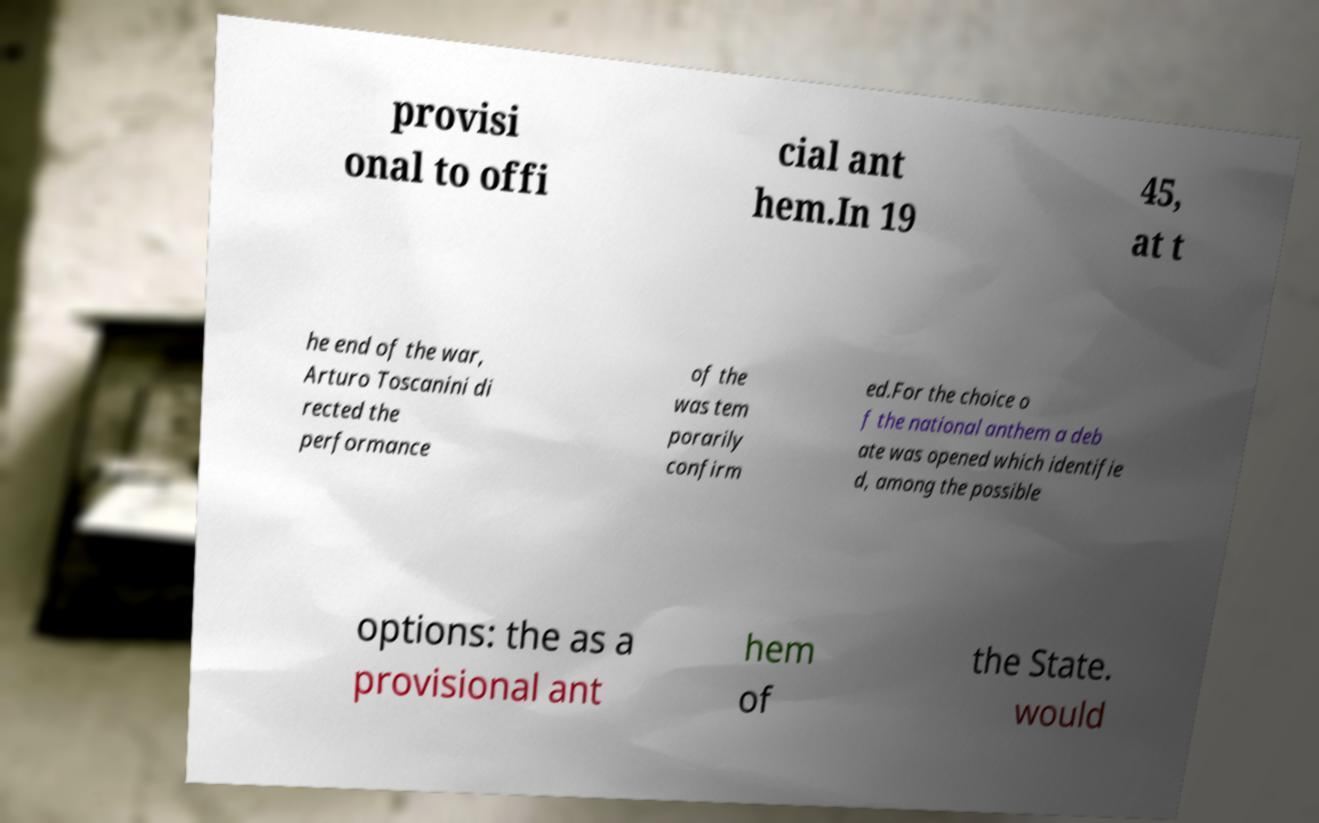I need the written content from this picture converted into text. Can you do that? provisi onal to offi cial ant hem.In 19 45, at t he end of the war, Arturo Toscanini di rected the performance of the was tem porarily confirm ed.For the choice o f the national anthem a deb ate was opened which identifie d, among the possible options: the as a provisional ant hem of the State. would 